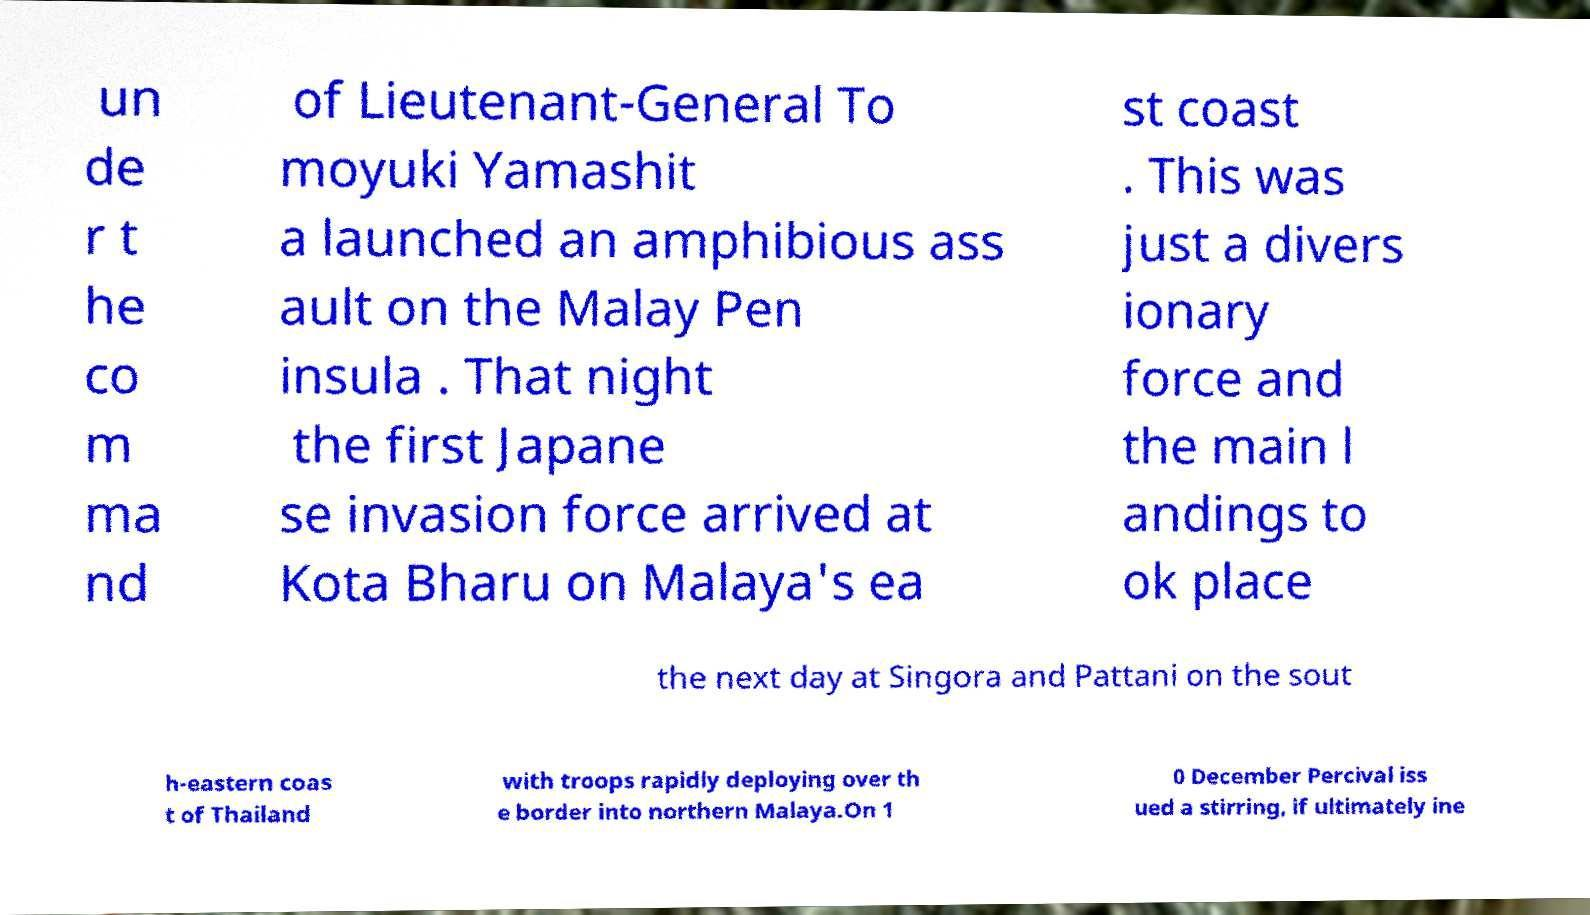For documentation purposes, I need the text within this image transcribed. Could you provide that? un de r t he co m ma nd of Lieutenant-General To moyuki Yamashit a launched an amphibious ass ault on the Malay Pen insula . That night the first Japane se invasion force arrived at Kota Bharu on Malaya's ea st coast . This was just a divers ionary force and the main l andings to ok place the next day at Singora and Pattani on the sout h-eastern coas t of Thailand with troops rapidly deploying over th e border into northern Malaya.On 1 0 December Percival iss ued a stirring, if ultimately ine 